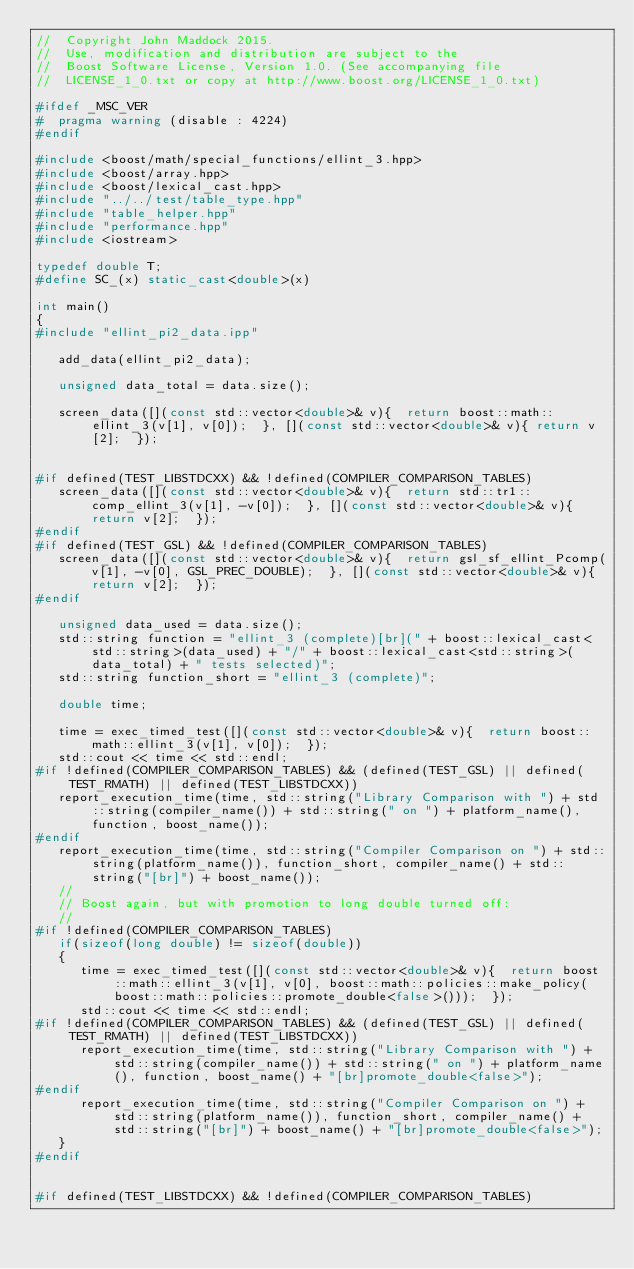<code> <loc_0><loc_0><loc_500><loc_500><_C++_>//  Copyright John Maddock 2015.
//  Use, modification and distribution are subject to the
//  Boost Software License, Version 1.0. (See accompanying file
//  LICENSE_1_0.txt or copy at http://www.boost.org/LICENSE_1_0.txt)

#ifdef _MSC_VER
#  pragma warning (disable : 4224)
#endif

#include <boost/math/special_functions/ellint_3.hpp>
#include <boost/array.hpp>
#include <boost/lexical_cast.hpp>
#include "../../test/table_type.hpp"
#include "table_helper.hpp"
#include "performance.hpp"
#include <iostream>

typedef double T;
#define SC_(x) static_cast<double>(x)

int main()
{
#include "ellint_pi2_data.ipp"

   add_data(ellint_pi2_data);

   unsigned data_total = data.size();

   screen_data([](const std::vector<double>& v){  return boost::math::ellint_3(v[1], v[0]);  }, [](const std::vector<double>& v){ return v[2];  });


#if defined(TEST_LIBSTDCXX) && !defined(COMPILER_COMPARISON_TABLES)
   screen_data([](const std::vector<double>& v){  return std::tr1::comp_ellint_3(v[1], -v[0]);  }, [](const std::vector<double>& v){ return v[2];  });
#endif
#if defined(TEST_GSL) && !defined(COMPILER_COMPARISON_TABLES)
   screen_data([](const std::vector<double>& v){  return gsl_sf_ellint_Pcomp(v[1], -v[0], GSL_PREC_DOUBLE);  }, [](const std::vector<double>& v){ return v[2];  });
#endif

   unsigned data_used = data.size();
   std::string function = "ellint_3 (complete)[br](" + boost::lexical_cast<std::string>(data_used) + "/" + boost::lexical_cast<std::string>(data_total) + " tests selected)";
   std::string function_short = "ellint_3 (complete)";

   double time;

   time = exec_timed_test([](const std::vector<double>& v){  return boost::math::ellint_3(v[1], v[0]);  });
   std::cout << time << std::endl;
#if !defined(COMPILER_COMPARISON_TABLES) && (defined(TEST_GSL) || defined(TEST_RMATH) || defined(TEST_LIBSTDCXX))
   report_execution_time(time, std::string("Library Comparison with ") + std::string(compiler_name()) + std::string(" on ") + platform_name(), function, boost_name());
#endif
   report_execution_time(time, std::string("Compiler Comparison on ") + std::string(platform_name()), function_short, compiler_name() + std::string("[br]") + boost_name());
   //
   // Boost again, but with promotion to long double turned off:
   //
#if !defined(COMPILER_COMPARISON_TABLES)
   if(sizeof(long double) != sizeof(double))
   {
      time = exec_timed_test([](const std::vector<double>& v){  return boost::math::ellint_3(v[1], v[0], boost::math::policies::make_policy(boost::math::policies::promote_double<false>()));  });
      std::cout << time << std::endl;
#if !defined(COMPILER_COMPARISON_TABLES) && (defined(TEST_GSL) || defined(TEST_RMATH) || defined(TEST_LIBSTDCXX))
      report_execution_time(time, std::string("Library Comparison with ") + std::string(compiler_name()) + std::string(" on ") + platform_name(), function, boost_name() + "[br]promote_double<false>");
#endif
      report_execution_time(time, std::string("Compiler Comparison on ") + std::string(platform_name()), function_short, compiler_name() + std::string("[br]") + boost_name() + "[br]promote_double<false>");
   }
#endif


#if defined(TEST_LIBSTDCXX) && !defined(COMPILER_COMPARISON_TABLES)</code> 